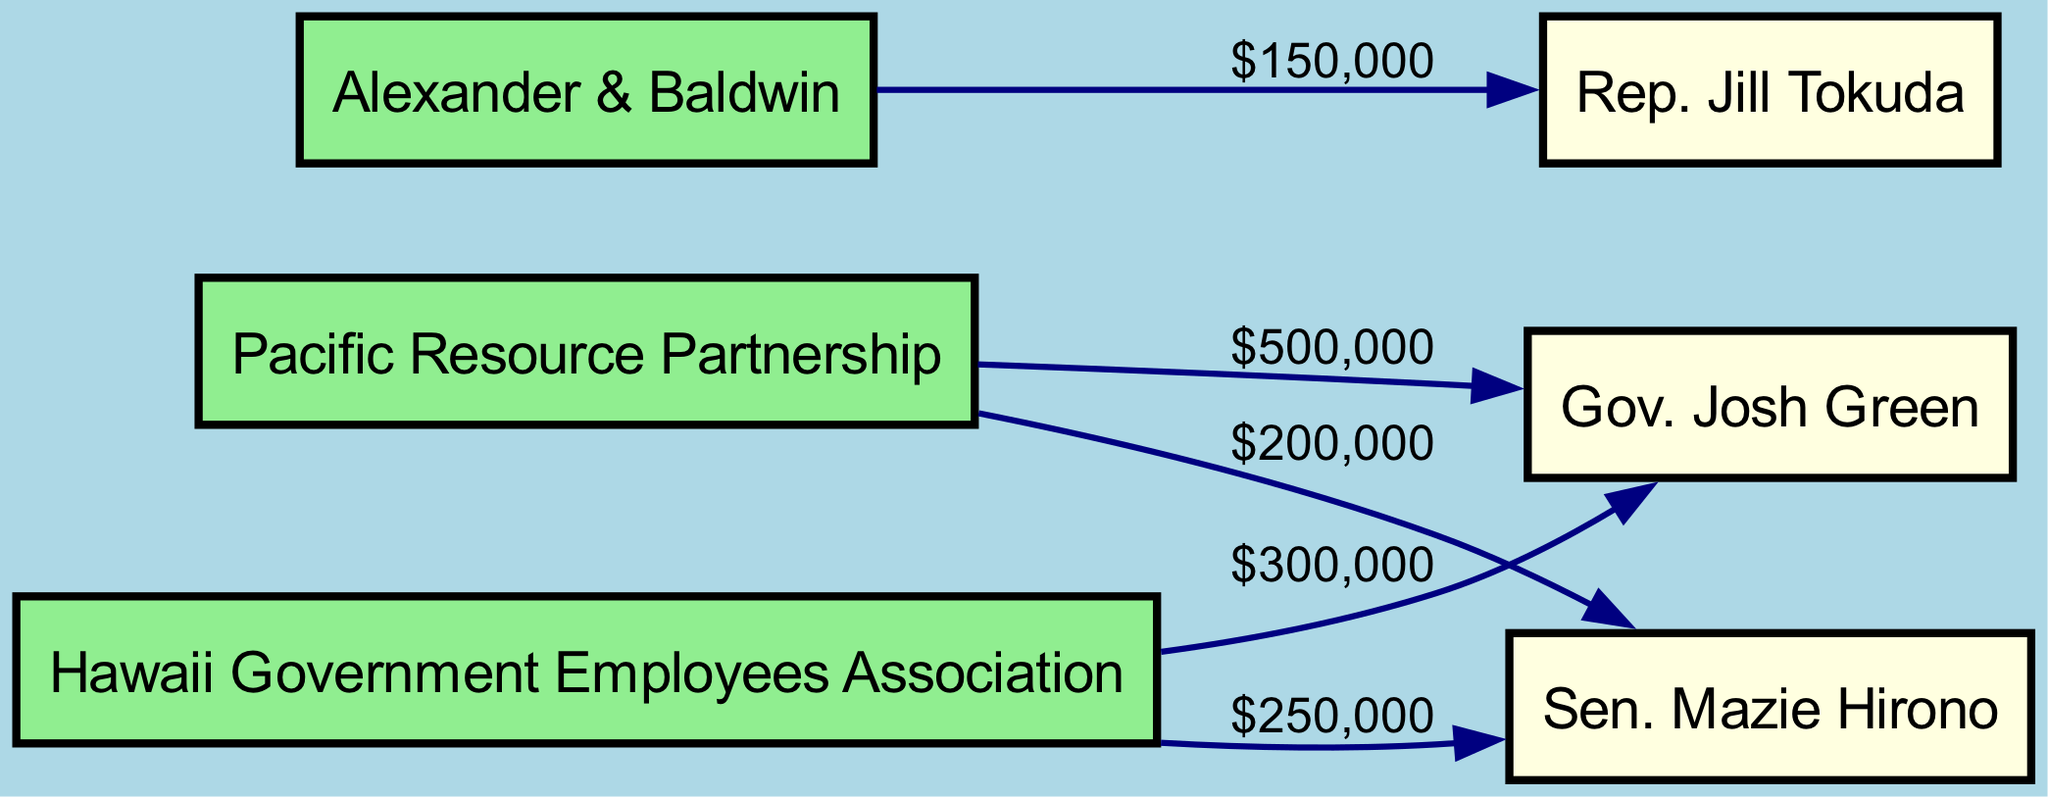What is the total amount donated by Pacific Resource Partnership? In the diagram, Pacific Resource Partnership has two edges leading to elected officials: one to Gov. Josh Green for $500,000 and one to Sen. Mazie Hirono for $200,000. Adding these amounts gives a total of $500,000 + $200,000 = $700,000.
Answer: $700,000 Which elected official received the highest single donation? The diagram shows that Gov. Josh Green received a donation of $500,000 from Pacific Resource Partnership, which is higher than any single donation to other officials.
Answer: Gov. Josh Green How many major donors are depicted in the diagram? The diagram lists three major donors: Pacific Resource Partnership, Hawaii Government Employees Association, and Alexander & Baldwin. Counting these gives a total of three major donors.
Answer: 3 What is the total amount donated to Sen. Mazie Hirono? There are two donations to Sen. Mazie Hirono: $250,000 from Hawaii Government Employees Association and $200,000 from Pacific Resource Partnership. Adding these amounts gives $250,000 + $200,000 = $450,000.
Answer: $450,000 Which major donor contributed to both Gov. Josh Green and Sen. Mazie Hirono? The diagram indicates that Pacific Resource Partnership is the major donor that contributed to both officials: $500,000 to Gov. Josh Green and $200,000 to Sen. Mazie Hirono.
Answer: Pacific Resource Partnership What is the smallest donation amount shown in the diagram? Analyzing the donations in the edges, the smallest amount is $150,000, which was donated by Alexander & Baldwin to Rep. Jill Tokuda.
Answer: $150,000 How many edges are there in the diagram? The diagram has a total of five edges connecting the nodes. They represent donations from major donors to elected officials. Counting these edges gives a total of five.
Answer: 5 Which elected official received funds from both the Hawaii Government Employees Association and another major donor? Gov. Josh Green received donations from Hawaii Government Employees Association amounting to $300,000 and also from Pacific Resource Partnership for $500,000. Therefore, the answer is Gov. Josh Green.
Answer: Gov. Josh Green What type of relationship is illustrated by the edges in this diagram? The edges represent financial contributions made by major donors to elected officials, indicating a transactional relationship between the two types of nodes.
Answer: Financial contributions 